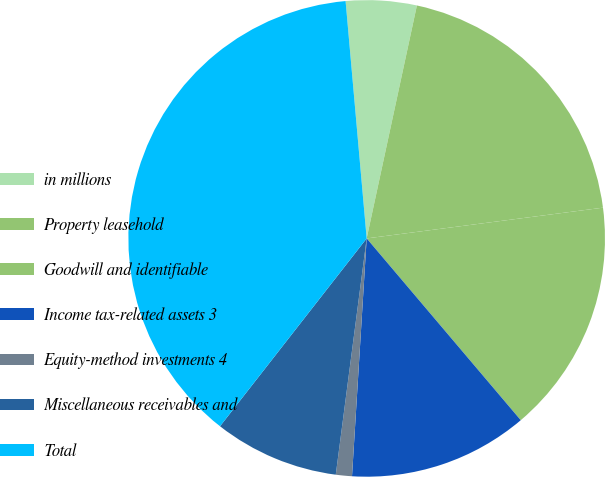Convert chart. <chart><loc_0><loc_0><loc_500><loc_500><pie_chart><fcel>in millions<fcel>Property leasehold<fcel>Goodwill and identifiable<fcel>Income tax-related assets 3<fcel>Equity-method investments 4<fcel>Miscellaneous receivables and<fcel>Total<nl><fcel>4.79%<fcel>19.56%<fcel>15.87%<fcel>12.17%<fcel>1.09%<fcel>8.48%<fcel>38.04%<nl></chart> 